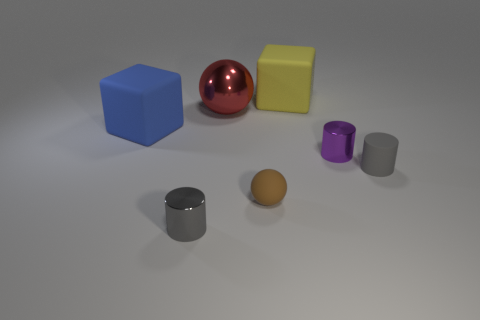Add 2 cubes. How many objects exist? 9 Subtract all cubes. How many objects are left? 5 Subtract 0 blue cylinders. How many objects are left? 7 Subtract all metal objects. Subtract all small brown rubber objects. How many objects are left? 3 Add 3 tiny brown things. How many tiny brown things are left? 4 Add 6 big green matte things. How many big green matte things exist? 6 